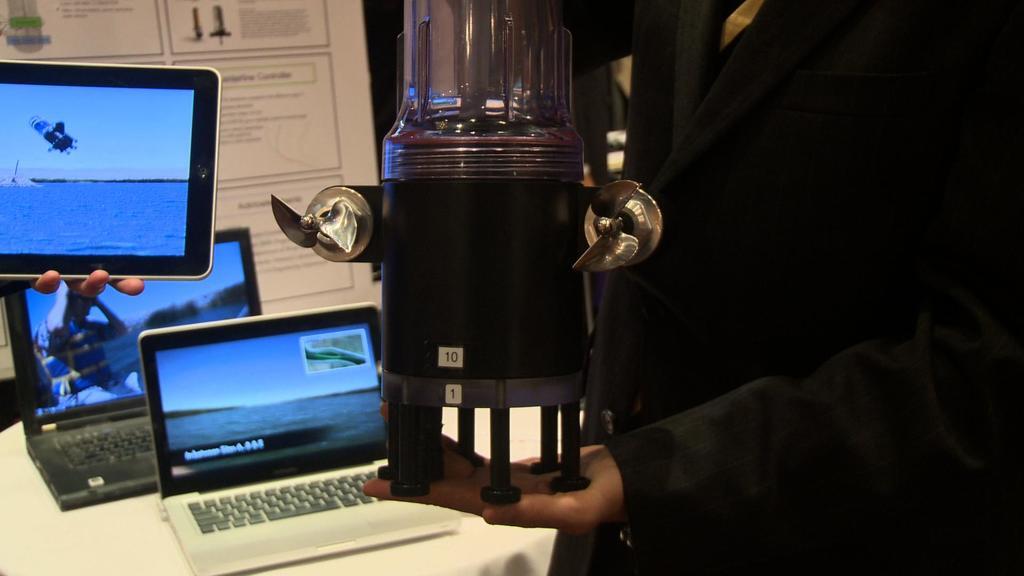What number is on the black machine?
Offer a very short reply. 10. 